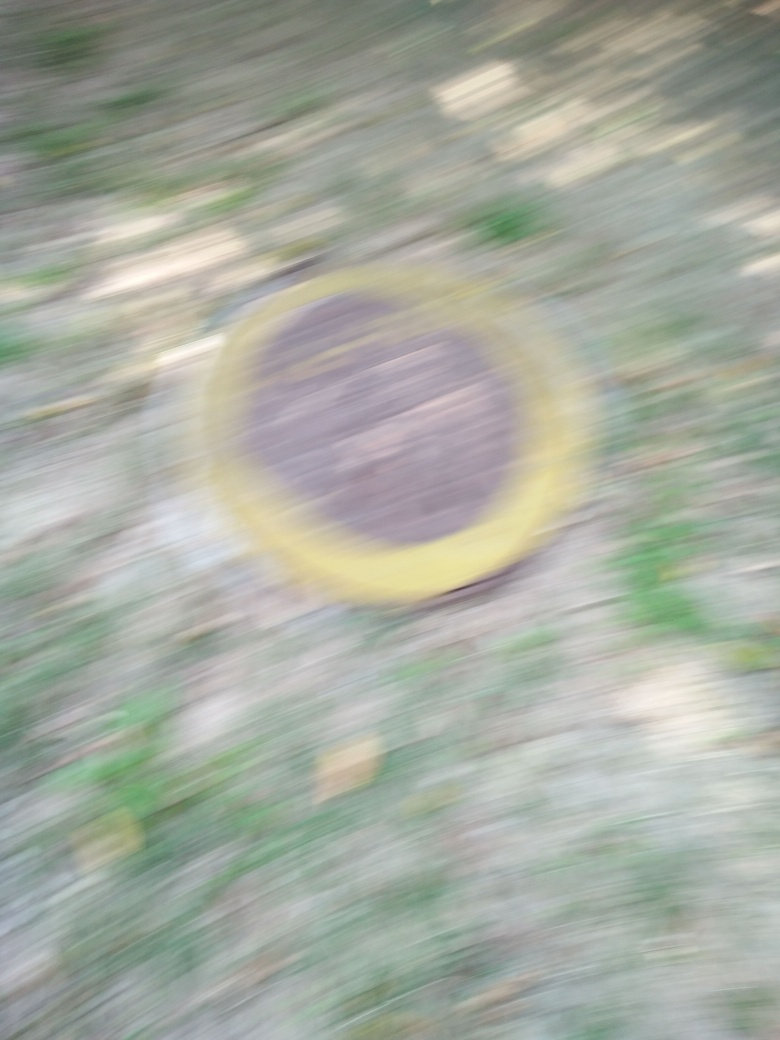Can you tell me more about what the circular object is supposed to be? While the specifics are obscured due to the motion blur, the circular object might be a manhole cover or a decorative element on the ground, typically found in urban settings. The yellow outer ring suggests it might be intended for visibility or safety. 